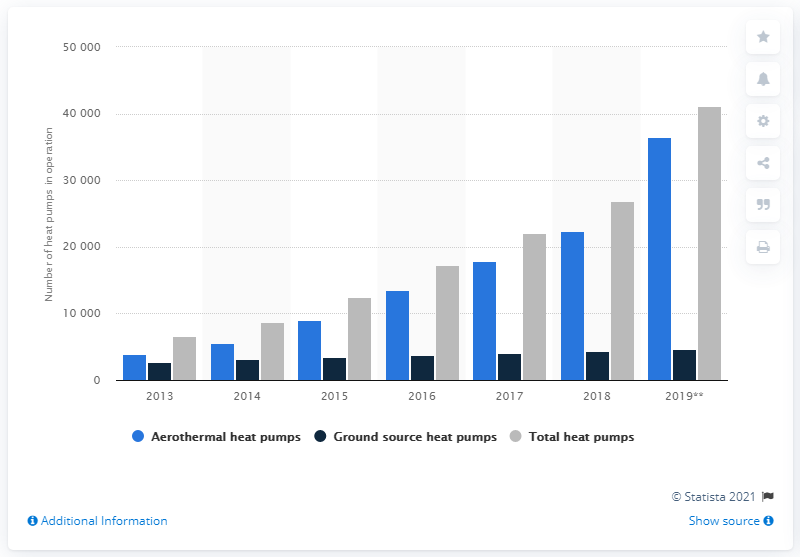Indicate a few pertinent items in this graphic. In 2019, the number of heat pumps in Ireland was 41,158. 